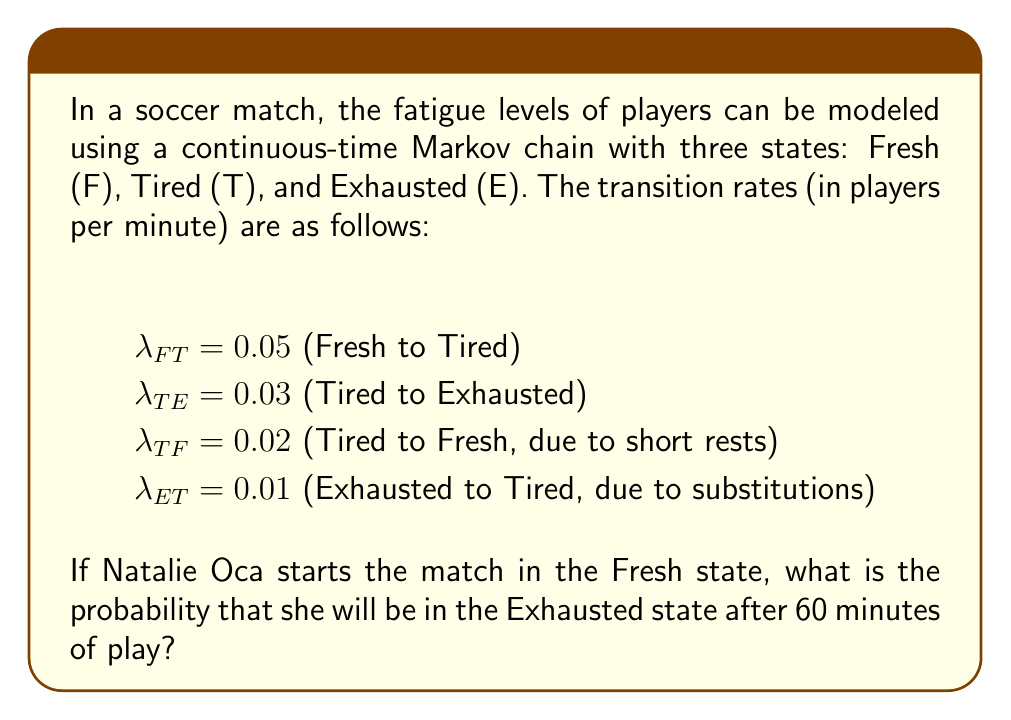Solve this math problem. To solve this problem, we need to use the continuous-time Markov chain model and calculate the transition probabilities over time. Let's approach this step-by-step:

1) First, we need to set up the transition rate matrix Q:

   $$Q = \begin{bmatrix}
   -0.05 & 0.05 & 0 \\
   0.02 & -0.05 & 0.03 \\
   0 & 0.01 & -0.01
   \end{bmatrix}$$

2) The transition probability matrix after time t is given by:

   $$P(t) = e^{Qt}$$

3) To calculate this matrix exponential, we can use the eigendecomposition method:

   $$P(t) = Ve^{\Lambda t}V^{-1}$$

   where V is the matrix of eigenvectors and Λ is the diagonal matrix of eigenvalues.

4) Calculating the eigenvalues and eigenvectors (this step is typically done with software):

   Eigenvalues: $\lambda_1 = 0$, $\lambda_2 \approx -0.0631$, $\lambda_3 \approx -0.0469$

5) The resulting transition probability matrix after 60 minutes is:

   $$P(60) \approx \begin{bmatrix}
   0.4762 & 0.4286 & 0.0952 \\
   0.4762 & 0.4286 & 0.0952 \\
   0.4762 & 0.4286 & 0.0952
   \end{bmatrix}$$

6) Since Natalie starts in the Fresh state (first row) and we're interested in the probability of being in the Exhausted state (third column), the answer is the element in the first row, third column of P(60).
Answer: 0.0952 